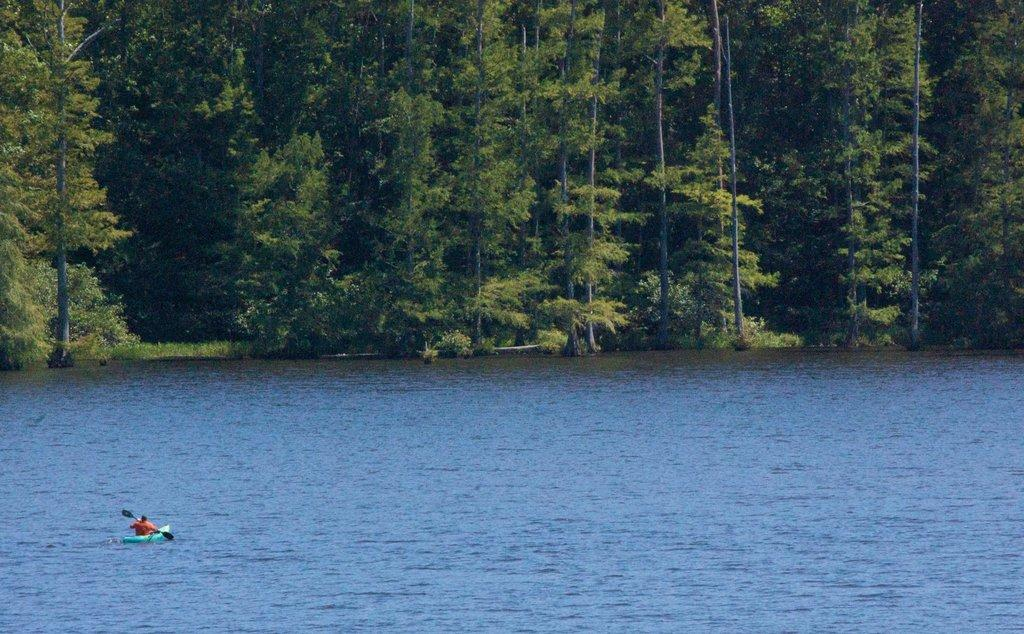What is the person in the image doing? The person is sitting on a boat. What is the person holding in the image? The person is holding a paddle. What is the color of the water in the image? The water in the image is blue. What can be seen in the background of the image? There are many trees in the background of the image. What type of powder is being used by the person in the image? There is no powder present in the image; the person is holding a paddle and sitting on a boat. 